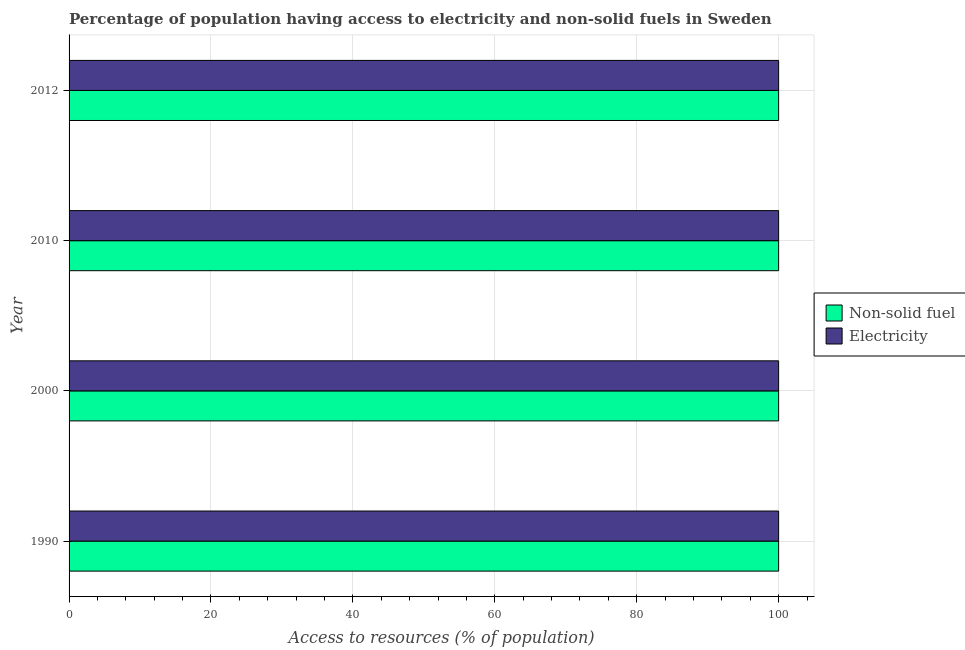How many different coloured bars are there?
Give a very brief answer. 2. What is the percentage of population having access to non-solid fuel in 1990?
Provide a short and direct response. 100. Across all years, what is the maximum percentage of population having access to electricity?
Make the answer very short. 100. Across all years, what is the minimum percentage of population having access to electricity?
Give a very brief answer. 100. In which year was the percentage of population having access to electricity minimum?
Provide a short and direct response. 1990. What is the total percentage of population having access to non-solid fuel in the graph?
Make the answer very short. 400. What is the difference between the percentage of population having access to non-solid fuel in 2010 and that in 2012?
Give a very brief answer. 0. What is the ratio of the percentage of population having access to electricity in 1990 to that in 2012?
Offer a terse response. 1. What is the difference between the highest and the lowest percentage of population having access to electricity?
Offer a very short reply. 0. What does the 2nd bar from the top in 1990 represents?
Ensure brevity in your answer.  Non-solid fuel. What does the 2nd bar from the bottom in 1990 represents?
Your answer should be very brief. Electricity. Are all the bars in the graph horizontal?
Offer a very short reply. Yes. Does the graph contain any zero values?
Your answer should be compact. No. Does the graph contain grids?
Offer a very short reply. Yes. What is the title of the graph?
Your answer should be very brief. Percentage of population having access to electricity and non-solid fuels in Sweden. Does "Rural Population" appear as one of the legend labels in the graph?
Give a very brief answer. No. What is the label or title of the X-axis?
Provide a short and direct response. Access to resources (% of population). What is the label or title of the Y-axis?
Provide a succinct answer. Year. What is the Access to resources (% of population) in Electricity in 1990?
Ensure brevity in your answer.  100. What is the Access to resources (% of population) of Non-solid fuel in 2000?
Keep it short and to the point. 100. What is the Access to resources (% of population) in Non-solid fuel in 2010?
Give a very brief answer. 100. What is the Access to resources (% of population) in Electricity in 2010?
Offer a very short reply. 100. What is the Access to resources (% of population) of Electricity in 2012?
Offer a terse response. 100. Across all years, what is the maximum Access to resources (% of population) of Electricity?
Give a very brief answer. 100. Across all years, what is the minimum Access to resources (% of population) in Electricity?
Provide a short and direct response. 100. What is the total Access to resources (% of population) in Electricity in the graph?
Provide a short and direct response. 400. What is the difference between the Access to resources (% of population) of Non-solid fuel in 1990 and that in 2012?
Keep it short and to the point. 0. What is the difference between the Access to resources (% of population) of Non-solid fuel in 2000 and that in 2010?
Your answer should be very brief. 0. What is the difference between the Access to resources (% of population) in Electricity in 2000 and that in 2010?
Your answer should be very brief. 0. What is the difference between the Access to resources (% of population) of Non-solid fuel in 2000 and that in 2012?
Make the answer very short. 0. What is the difference between the Access to resources (% of population) of Non-solid fuel in 2010 and that in 2012?
Offer a terse response. 0. What is the difference between the Access to resources (% of population) of Non-solid fuel in 2000 and the Access to resources (% of population) of Electricity in 2010?
Provide a succinct answer. 0. What is the difference between the Access to resources (% of population) in Non-solid fuel in 2000 and the Access to resources (% of population) in Electricity in 2012?
Offer a terse response. 0. What is the average Access to resources (% of population) in Electricity per year?
Provide a succinct answer. 100. In the year 1990, what is the difference between the Access to resources (% of population) in Non-solid fuel and Access to resources (% of population) in Electricity?
Give a very brief answer. 0. In the year 2012, what is the difference between the Access to resources (% of population) in Non-solid fuel and Access to resources (% of population) in Electricity?
Your answer should be very brief. 0. What is the ratio of the Access to resources (% of population) in Electricity in 1990 to that in 2010?
Your answer should be very brief. 1. What is the ratio of the Access to resources (% of population) of Non-solid fuel in 1990 to that in 2012?
Provide a short and direct response. 1. What is the ratio of the Access to resources (% of population) in Electricity in 1990 to that in 2012?
Offer a very short reply. 1. What is the ratio of the Access to resources (% of population) of Non-solid fuel in 2000 to that in 2010?
Give a very brief answer. 1. What is the ratio of the Access to resources (% of population) of Non-solid fuel in 2010 to that in 2012?
Your answer should be compact. 1. What is the difference between the highest and the second highest Access to resources (% of population) in Non-solid fuel?
Ensure brevity in your answer.  0. What is the difference between the highest and the second highest Access to resources (% of population) in Electricity?
Make the answer very short. 0. What is the difference between the highest and the lowest Access to resources (% of population) in Non-solid fuel?
Keep it short and to the point. 0. 